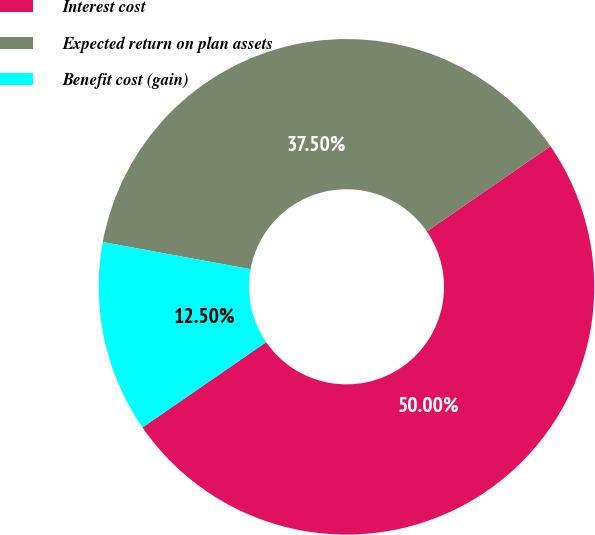Convert chart. <chart><loc_0><loc_0><loc_500><loc_500><pie_chart><fcel>Interest cost<fcel>Expected return on plan assets<fcel>Benefit cost (gain)<nl><fcel>50.0%<fcel>37.5%<fcel>12.5%<nl></chart> 